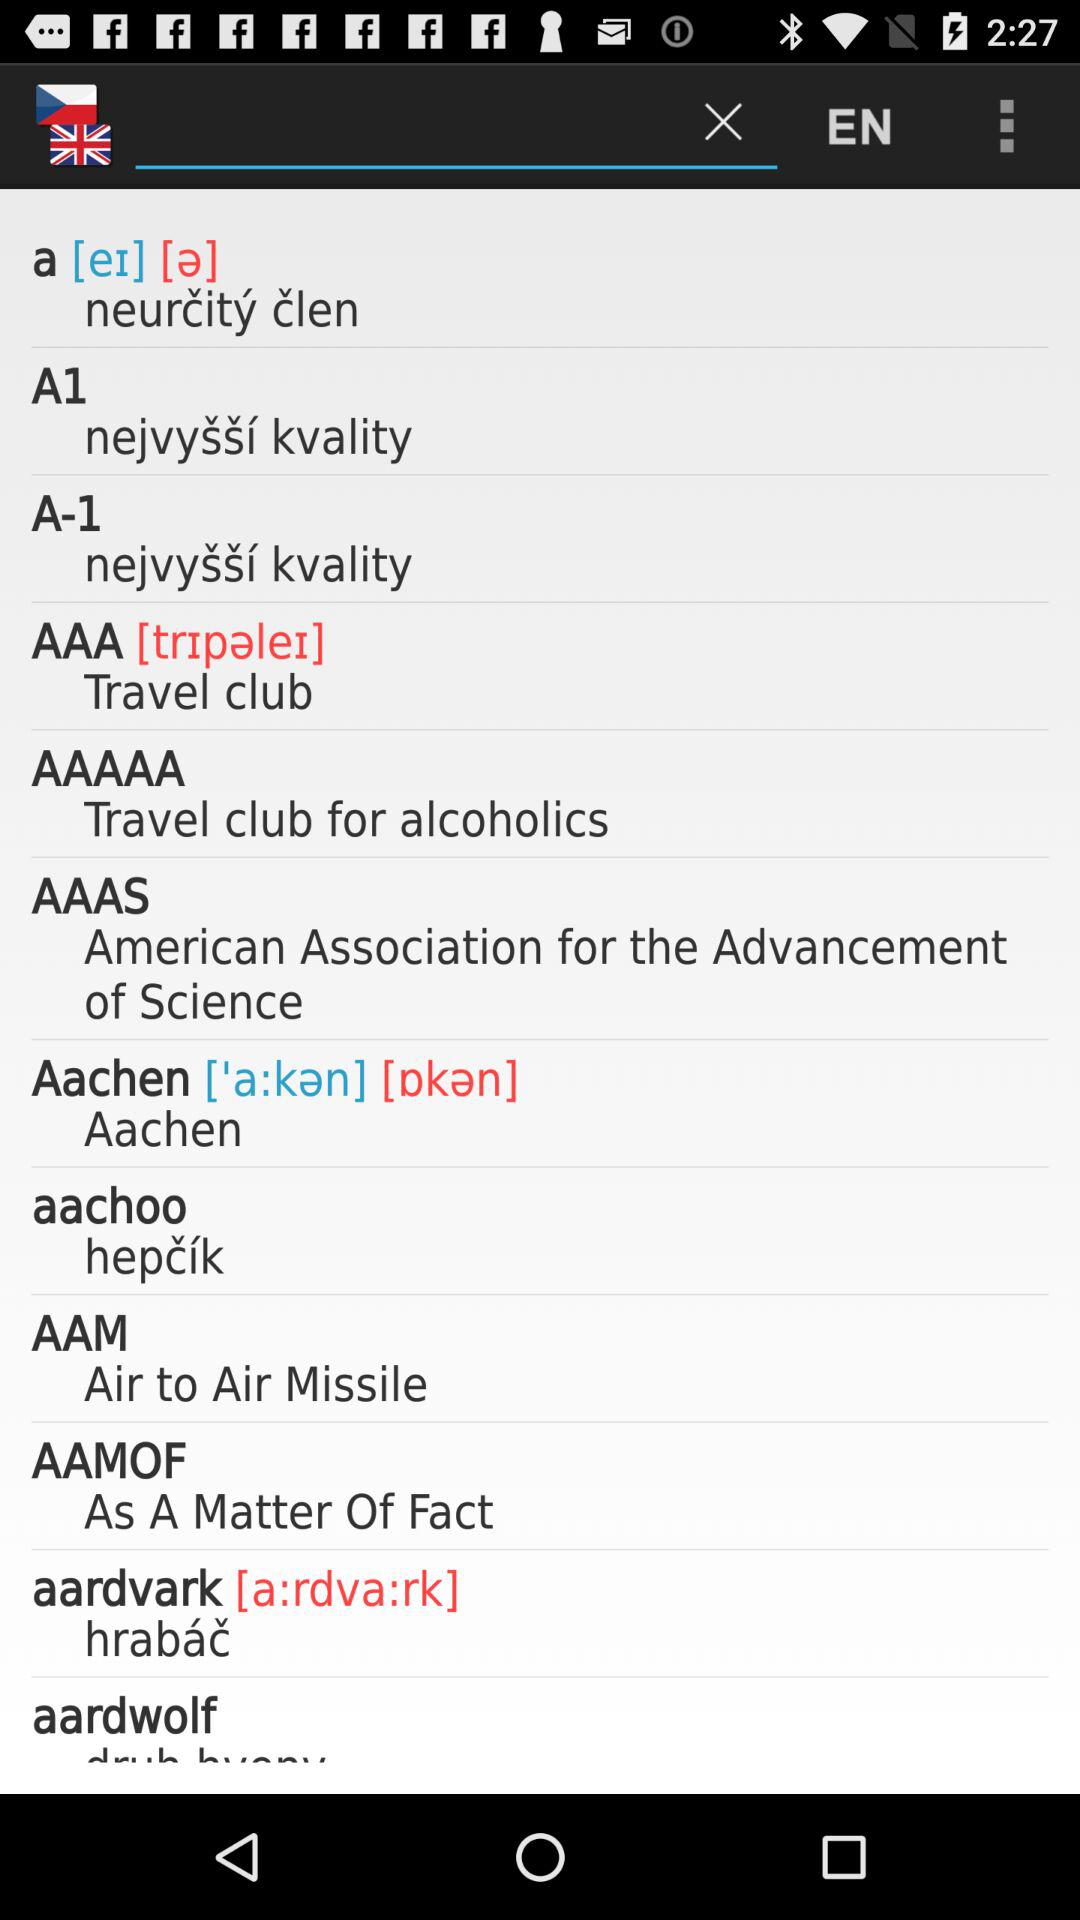What is the full form of AAM? The full form of AAM is "Air to Air Missile". 